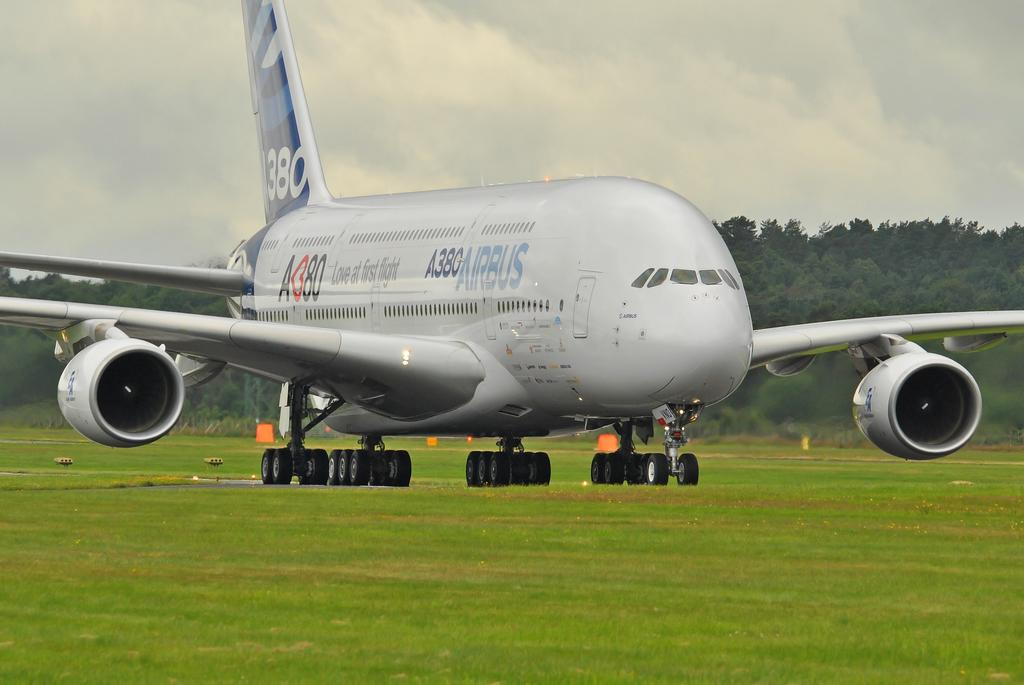<image>
Give a short and clear explanation of the subsequent image. An Airbus A380 airplane is touched down on landing strip 